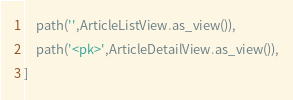Convert code to text. <code><loc_0><loc_0><loc_500><loc_500><_Python_>    path('',ArticleListView.as_view()),
    path('<pk>',ArticleDetailView.as_view()),
]</code> 